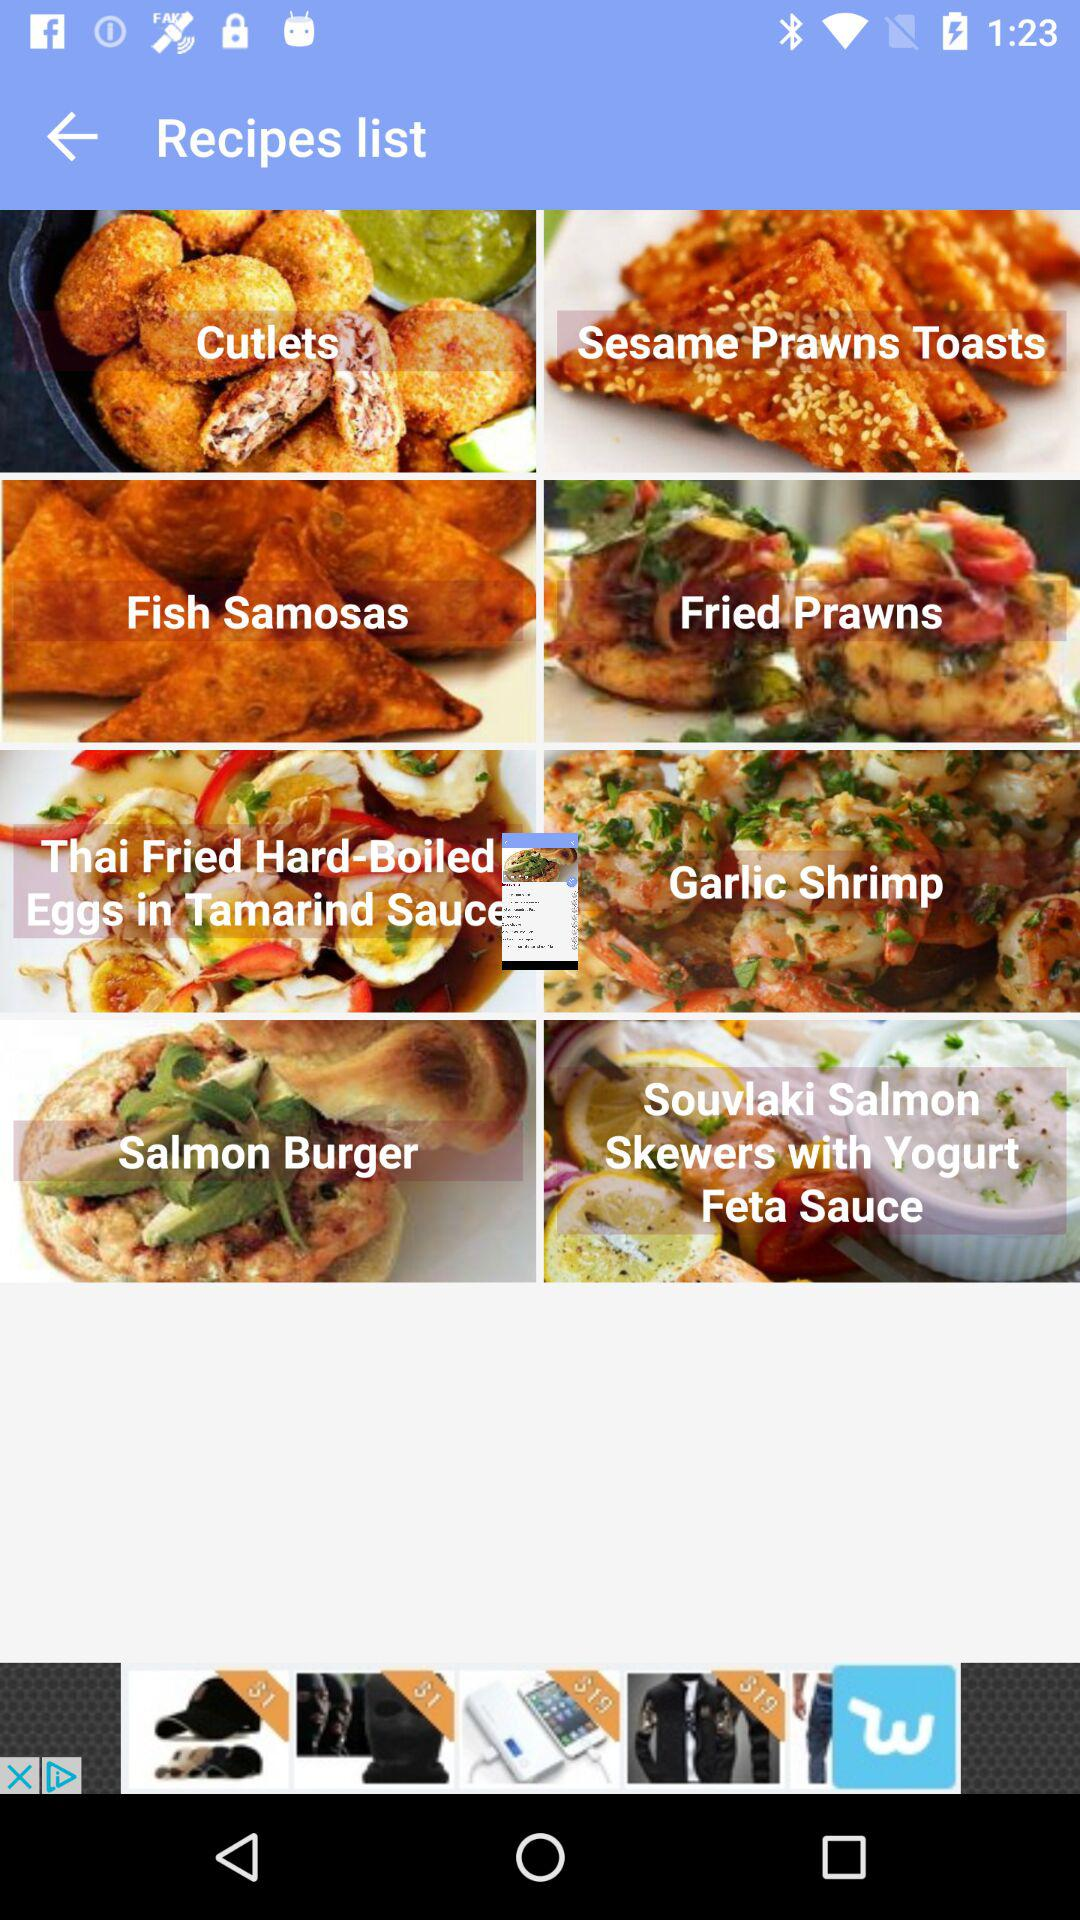What type of samosa is on the recipe list? The type of samosa is fish samosa. 